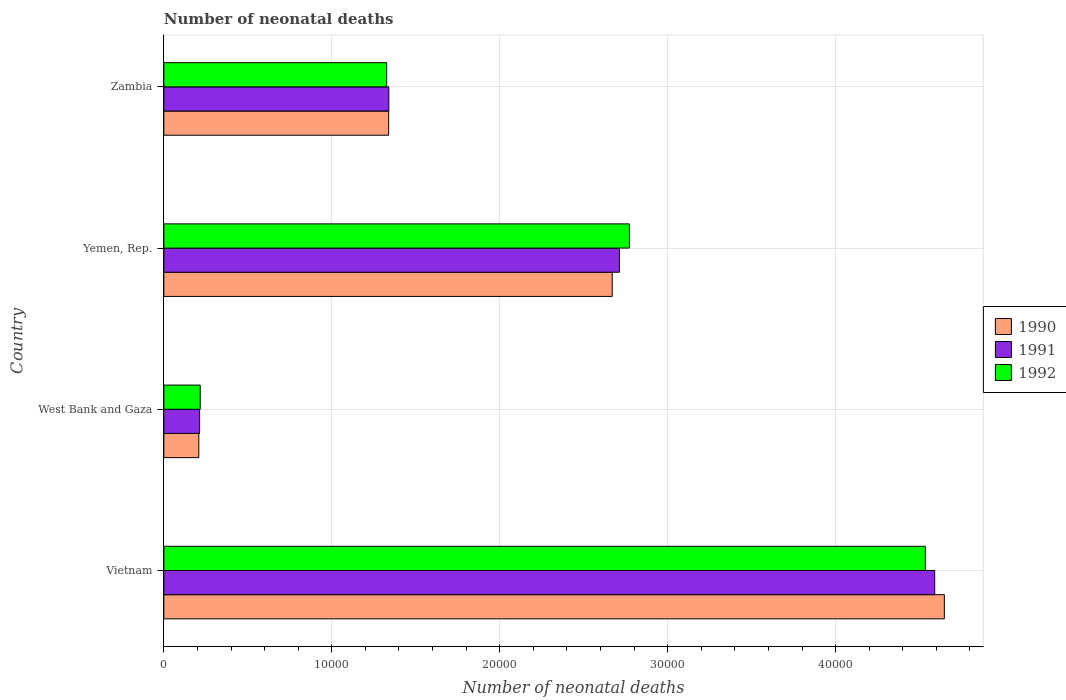How many different coloured bars are there?
Your answer should be compact. 3. How many groups of bars are there?
Ensure brevity in your answer.  4. Are the number of bars on each tick of the Y-axis equal?
Make the answer very short. Yes. How many bars are there on the 4th tick from the bottom?
Offer a terse response. 3. What is the label of the 2nd group of bars from the top?
Offer a very short reply. Yemen, Rep. In how many cases, is the number of bars for a given country not equal to the number of legend labels?
Offer a very short reply. 0. What is the number of neonatal deaths in in 1990 in West Bank and Gaza?
Give a very brief answer. 2084. Across all countries, what is the maximum number of neonatal deaths in in 1991?
Your answer should be compact. 4.59e+04. Across all countries, what is the minimum number of neonatal deaths in in 1990?
Ensure brevity in your answer.  2084. In which country was the number of neonatal deaths in in 1992 maximum?
Offer a terse response. Vietnam. In which country was the number of neonatal deaths in in 1992 minimum?
Provide a succinct answer. West Bank and Gaza. What is the total number of neonatal deaths in in 1990 in the graph?
Provide a succinct answer. 8.86e+04. What is the difference between the number of neonatal deaths in in 1991 in Vietnam and that in West Bank and Gaza?
Your answer should be compact. 4.38e+04. What is the difference between the number of neonatal deaths in in 1991 in West Bank and Gaza and the number of neonatal deaths in in 1992 in Vietnam?
Make the answer very short. -4.32e+04. What is the average number of neonatal deaths in in 1991 per country?
Provide a succinct answer. 2.21e+04. What is the difference between the number of neonatal deaths in in 1991 and number of neonatal deaths in in 1990 in Vietnam?
Your response must be concise. -574. In how many countries, is the number of neonatal deaths in in 1992 greater than 34000 ?
Your answer should be very brief. 1. What is the ratio of the number of neonatal deaths in in 1990 in Vietnam to that in Zambia?
Offer a terse response. 3.47. What is the difference between the highest and the second highest number of neonatal deaths in in 1992?
Offer a terse response. 1.76e+04. What is the difference between the highest and the lowest number of neonatal deaths in in 1990?
Your answer should be very brief. 4.44e+04. Is the sum of the number of neonatal deaths in in 1991 in West Bank and Gaza and Yemen, Rep. greater than the maximum number of neonatal deaths in in 1990 across all countries?
Provide a short and direct response. No. What does the 3rd bar from the bottom in West Bank and Gaza represents?
Keep it short and to the point. 1992. Are all the bars in the graph horizontal?
Offer a very short reply. Yes. Are the values on the major ticks of X-axis written in scientific E-notation?
Your answer should be very brief. No. Does the graph contain grids?
Ensure brevity in your answer.  Yes. How many legend labels are there?
Your answer should be very brief. 3. How are the legend labels stacked?
Ensure brevity in your answer.  Vertical. What is the title of the graph?
Keep it short and to the point. Number of neonatal deaths. Does "1977" appear as one of the legend labels in the graph?
Your response must be concise. No. What is the label or title of the X-axis?
Provide a succinct answer. Number of neonatal deaths. What is the label or title of the Y-axis?
Ensure brevity in your answer.  Country. What is the Number of neonatal deaths of 1990 in Vietnam?
Your answer should be very brief. 4.65e+04. What is the Number of neonatal deaths of 1991 in Vietnam?
Provide a succinct answer. 4.59e+04. What is the Number of neonatal deaths of 1992 in Vietnam?
Provide a short and direct response. 4.53e+04. What is the Number of neonatal deaths in 1990 in West Bank and Gaza?
Make the answer very short. 2084. What is the Number of neonatal deaths in 1991 in West Bank and Gaza?
Offer a very short reply. 2130. What is the Number of neonatal deaths in 1992 in West Bank and Gaza?
Offer a very short reply. 2167. What is the Number of neonatal deaths in 1990 in Yemen, Rep.?
Offer a terse response. 2.67e+04. What is the Number of neonatal deaths in 1991 in Yemen, Rep.?
Your response must be concise. 2.71e+04. What is the Number of neonatal deaths of 1992 in Yemen, Rep.?
Your answer should be compact. 2.77e+04. What is the Number of neonatal deaths of 1990 in Zambia?
Offer a terse response. 1.34e+04. What is the Number of neonatal deaths of 1991 in Zambia?
Ensure brevity in your answer.  1.34e+04. What is the Number of neonatal deaths of 1992 in Zambia?
Provide a succinct answer. 1.33e+04. Across all countries, what is the maximum Number of neonatal deaths in 1990?
Make the answer very short. 4.65e+04. Across all countries, what is the maximum Number of neonatal deaths in 1991?
Give a very brief answer. 4.59e+04. Across all countries, what is the maximum Number of neonatal deaths of 1992?
Give a very brief answer. 4.53e+04. Across all countries, what is the minimum Number of neonatal deaths in 1990?
Your response must be concise. 2084. Across all countries, what is the minimum Number of neonatal deaths of 1991?
Your answer should be very brief. 2130. Across all countries, what is the minimum Number of neonatal deaths in 1992?
Make the answer very short. 2167. What is the total Number of neonatal deaths of 1990 in the graph?
Offer a terse response. 8.86e+04. What is the total Number of neonatal deaths in 1991 in the graph?
Ensure brevity in your answer.  8.86e+04. What is the total Number of neonatal deaths in 1992 in the graph?
Ensure brevity in your answer.  8.85e+04. What is the difference between the Number of neonatal deaths of 1990 in Vietnam and that in West Bank and Gaza?
Provide a succinct answer. 4.44e+04. What is the difference between the Number of neonatal deaths in 1991 in Vietnam and that in West Bank and Gaza?
Give a very brief answer. 4.38e+04. What is the difference between the Number of neonatal deaths in 1992 in Vietnam and that in West Bank and Gaza?
Keep it short and to the point. 4.32e+04. What is the difference between the Number of neonatal deaths of 1990 in Vietnam and that in Yemen, Rep.?
Offer a very short reply. 1.98e+04. What is the difference between the Number of neonatal deaths in 1991 in Vietnam and that in Yemen, Rep.?
Your response must be concise. 1.88e+04. What is the difference between the Number of neonatal deaths in 1992 in Vietnam and that in Yemen, Rep.?
Your response must be concise. 1.76e+04. What is the difference between the Number of neonatal deaths of 1990 in Vietnam and that in Zambia?
Your answer should be compact. 3.31e+04. What is the difference between the Number of neonatal deaths in 1991 in Vietnam and that in Zambia?
Your answer should be compact. 3.25e+04. What is the difference between the Number of neonatal deaths of 1992 in Vietnam and that in Zambia?
Offer a very short reply. 3.21e+04. What is the difference between the Number of neonatal deaths in 1990 in West Bank and Gaza and that in Yemen, Rep.?
Give a very brief answer. -2.46e+04. What is the difference between the Number of neonatal deaths in 1991 in West Bank and Gaza and that in Yemen, Rep.?
Your response must be concise. -2.50e+04. What is the difference between the Number of neonatal deaths of 1992 in West Bank and Gaza and that in Yemen, Rep.?
Offer a terse response. -2.56e+04. What is the difference between the Number of neonatal deaths of 1990 in West Bank and Gaza and that in Zambia?
Your response must be concise. -1.13e+04. What is the difference between the Number of neonatal deaths of 1991 in West Bank and Gaza and that in Zambia?
Offer a very short reply. -1.13e+04. What is the difference between the Number of neonatal deaths of 1992 in West Bank and Gaza and that in Zambia?
Provide a succinct answer. -1.11e+04. What is the difference between the Number of neonatal deaths of 1990 in Yemen, Rep. and that in Zambia?
Keep it short and to the point. 1.33e+04. What is the difference between the Number of neonatal deaths of 1991 in Yemen, Rep. and that in Zambia?
Give a very brief answer. 1.37e+04. What is the difference between the Number of neonatal deaths in 1992 in Yemen, Rep. and that in Zambia?
Offer a terse response. 1.45e+04. What is the difference between the Number of neonatal deaths in 1990 in Vietnam and the Number of neonatal deaths in 1991 in West Bank and Gaza?
Offer a terse response. 4.43e+04. What is the difference between the Number of neonatal deaths in 1990 in Vietnam and the Number of neonatal deaths in 1992 in West Bank and Gaza?
Ensure brevity in your answer.  4.43e+04. What is the difference between the Number of neonatal deaths in 1991 in Vietnam and the Number of neonatal deaths in 1992 in West Bank and Gaza?
Keep it short and to the point. 4.37e+04. What is the difference between the Number of neonatal deaths in 1990 in Vietnam and the Number of neonatal deaths in 1991 in Yemen, Rep.?
Ensure brevity in your answer.  1.93e+04. What is the difference between the Number of neonatal deaths of 1990 in Vietnam and the Number of neonatal deaths of 1992 in Yemen, Rep.?
Ensure brevity in your answer.  1.88e+04. What is the difference between the Number of neonatal deaths in 1991 in Vietnam and the Number of neonatal deaths in 1992 in Yemen, Rep.?
Ensure brevity in your answer.  1.82e+04. What is the difference between the Number of neonatal deaths in 1990 in Vietnam and the Number of neonatal deaths in 1991 in Zambia?
Offer a very short reply. 3.31e+04. What is the difference between the Number of neonatal deaths of 1990 in Vietnam and the Number of neonatal deaths of 1992 in Zambia?
Provide a short and direct response. 3.32e+04. What is the difference between the Number of neonatal deaths of 1991 in Vietnam and the Number of neonatal deaths of 1992 in Zambia?
Make the answer very short. 3.26e+04. What is the difference between the Number of neonatal deaths in 1990 in West Bank and Gaza and the Number of neonatal deaths in 1991 in Yemen, Rep.?
Offer a very short reply. -2.50e+04. What is the difference between the Number of neonatal deaths of 1990 in West Bank and Gaza and the Number of neonatal deaths of 1992 in Yemen, Rep.?
Make the answer very short. -2.56e+04. What is the difference between the Number of neonatal deaths of 1991 in West Bank and Gaza and the Number of neonatal deaths of 1992 in Yemen, Rep.?
Ensure brevity in your answer.  -2.56e+04. What is the difference between the Number of neonatal deaths in 1990 in West Bank and Gaza and the Number of neonatal deaths in 1991 in Zambia?
Your answer should be very brief. -1.13e+04. What is the difference between the Number of neonatal deaths of 1990 in West Bank and Gaza and the Number of neonatal deaths of 1992 in Zambia?
Offer a very short reply. -1.12e+04. What is the difference between the Number of neonatal deaths in 1991 in West Bank and Gaza and the Number of neonatal deaths in 1992 in Zambia?
Offer a terse response. -1.11e+04. What is the difference between the Number of neonatal deaths in 1990 in Yemen, Rep. and the Number of neonatal deaths in 1991 in Zambia?
Offer a terse response. 1.33e+04. What is the difference between the Number of neonatal deaths of 1990 in Yemen, Rep. and the Number of neonatal deaths of 1992 in Zambia?
Provide a succinct answer. 1.34e+04. What is the difference between the Number of neonatal deaths in 1991 in Yemen, Rep. and the Number of neonatal deaths in 1992 in Zambia?
Your response must be concise. 1.39e+04. What is the average Number of neonatal deaths in 1990 per country?
Your answer should be compact. 2.22e+04. What is the average Number of neonatal deaths of 1991 per country?
Your response must be concise. 2.21e+04. What is the average Number of neonatal deaths in 1992 per country?
Your response must be concise. 2.21e+04. What is the difference between the Number of neonatal deaths of 1990 and Number of neonatal deaths of 1991 in Vietnam?
Your answer should be compact. 574. What is the difference between the Number of neonatal deaths of 1990 and Number of neonatal deaths of 1992 in Vietnam?
Ensure brevity in your answer.  1131. What is the difference between the Number of neonatal deaths in 1991 and Number of neonatal deaths in 1992 in Vietnam?
Give a very brief answer. 557. What is the difference between the Number of neonatal deaths in 1990 and Number of neonatal deaths in 1991 in West Bank and Gaza?
Your answer should be compact. -46. What is the difference between the Number of neonatal deaths in 1990 and Number of neonatal deaths in 1992 in West Bank and Gaza?
Provide a short and direct response. -83. What is the difference between the Number of neonatal deaths of 1991 and Number of neonatal deaths of 1992 in West Bank and Gaza?
Your response must be concise. -37. What is the difference between the Number of neonatal deaths in 1990 and Number of neonatal deaths in 1991 in Yemen, Rep.?
Give a very brief answer. -430. What is the difference between the Number of neonatal deaths in 1990 and Number of neonatal deaths in 1992 in Yemen, Rep.?
Your answer should be very brief. -1024. What is the difference between the Number of neonatal deaths of 1991 and Number of neonatal deaths of 1992 in Yemen, Rep.?
Provide a succinct answer. -594. What is the difference between the Number of neonatal deaths in 1990 and Number of neonatal deaths in 1992 in Zambia?
Provide a short and direct response. 119. What is the difference between the Number of neonatal deaths of 1991 and Number of neonatal deaths of 1992 in Zambia?
Offer a very short reply. 128. What is the ratio of the Number of neonatal deaths in 1990 in Vietnam to that in West Bank and Gaza?
Give a very brief answer. 22.3. What is the ratio of the Number of neonatal deaths of 1991 in Vietnam to that in West Bank and Gaza?
Offer a terse response. 21.55. What is the ratio of the Number of neonatal deaths in 1992 in Vietnam to that in West Bank and Gaza?
Keep it short and to the point. 20.92. What is the ratio of the Number of neonatal deaths in 1990 in Vietnam to that in Yemen, Rep.?
Your answer should be very brief. 1.74. What is the ratio of the Number of neonatal deaths of 1991 in Vietnam to that in Yemen, Rep.?
Keep it short and to the point. 1.69. What is the ratio of the Number of neonatal deaths of 1992 in Vietnam to that in Yemen, Rep.?
Your answer should be very brief. 1.64. What is the ratio of the Number of neonatal deaths of 1990 in Vietnam to that in Zambia?
Provide a short and direct response. 3.47. What is the ratio of the Number of neonatal deaths in 1991 in Vietnam to that in Zambia?
Your answer should be compact. 3.43. What is the ratio of the Number of neonatal deaths of 1992 in Vietnam to that in Zambia?
Offer a terse response. 3.42. What is the ratio of the Number of neonatal deaths of 1990 in West Bank and Gaza to that in Yemen, Rep.?
Offer a very short reply. 0.08. What is the ratio of the Number of neonatal deaths in 1991 in West Bank and Gaza to that in Yemen, Rep.?
Ensure brevity in your answer.  0.08. What is the ratio of the Number of neonatal deaths of 1992 in West Bank and Gaza to that in Yemen, Rep.?
Make the answer very short. 0.08. What is the ratio of the Number of neonatal deaths of 1990 in West Bank and Gaza to that in Zambia?
Give a very brief answer. 0.16. What is the ratio of the Number of neonatal deaths of 1991 in West Bank and Gaza to that in Zambia?
Offer a very short reply. 0.16. What is the ratio of the Number of neonatal deaths of 1992 in West Bank and Gaza to that in Zambia?
Provide a succinct answer. 0.16. What is the ratio of the Number of neonatal deaths of 1990 in Yemen, Rep. to that in Zambia?
Provide a succinct answer. 1.99. What is the ratio of the Number of neonatal deaths in 1991 in Yemen, Rep. to that in Zambia?
Your response must be concise. 2.03. What is the ratio of the Number of neonatal deaths of 1992 in Yemen, Rep. to that in Zambia?
Ensure brevity in your answer.  2.09. What is the difference between the highest and the second highest Number of neonatal deaths of 1990?
Give a very brief answer. 1.98e+04. What is the difference between the highest and the second highest Number of neonatal deaths of 1991?
Your response must be concise. 1.88e+04. What is the difference between the highest and the second highest Number of neonatal deaths of 1992?
Ensure brevity in your answer.  1.76e+04. What is the difference between the highest and the lowest Number of neonatal deaths in 1990?
Offer a terse response. 4.44e+04. What is the difference between the highest and the lowest Number of neonatal deaths of 1991?
Provide a short and direct response. 4.38e+04. What is the difference between the highest and the lowest Number of neonatal deaths in 1992?
Keep it short and to the point. 4.32e+04. 